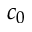<formula> <loc_0><loc_0><loc_500><loc_500>c _ { 0 }</formula> 